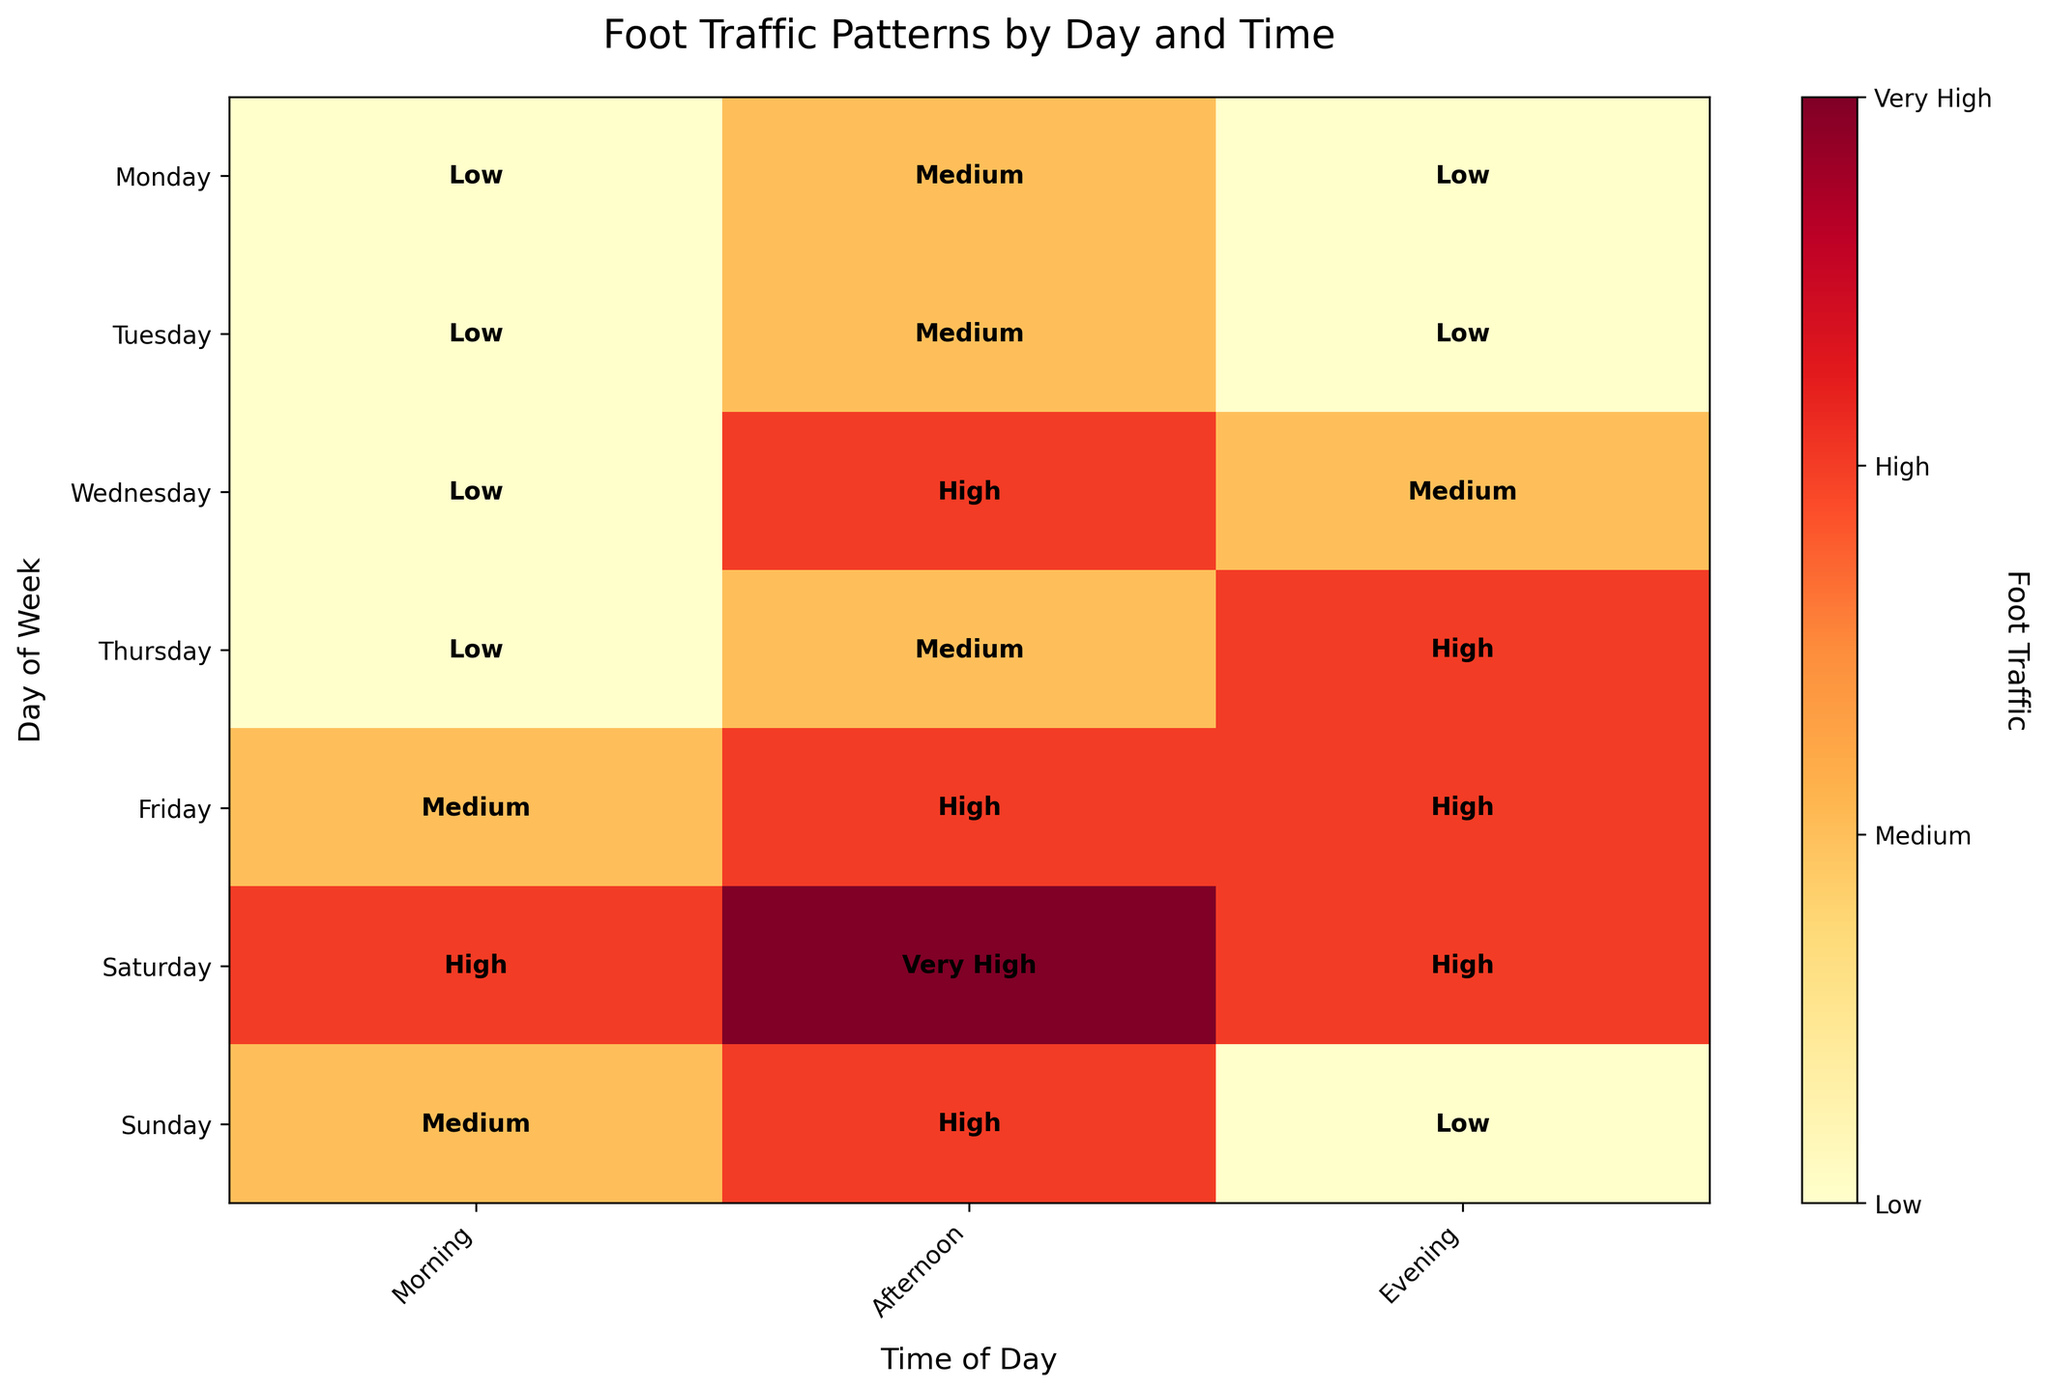What's the title of the plot? The title is usually placed at the top of the plot and provides a brief description of what the plot is about.
Answer: Foot Traffic Patterns by Day and Time Which day has the highest foot traffic in the afternoon? To determine this, locate the "Afternoon" column in the plot and identify the row with the darkest shade of color, which denotes the highest traffic.
Answer: Saturday How does Sunday evening foot traffic compare to Sunday morning foot traffic? Locate both the "Morning" and "Evening" cells for Sunday. Compare their shades—light shades for low traffic and darker shades for higher traffic.
Answer: Evening has lower traffic compared to Morning On which day and time does the foot traffic reach 'Very High'? Identify the darkest cell, which represents 'Very High', in both the days and times shown.
Answer: Saturday Afternoon What day and time of day has the lowest foot traffic overall? Look for the lightest shade in the entire plot, which signifies the lowest foot traffic.
Answer: Monday Morning How does Wednesday evening foot traffic compare to Thursday evening foot traffic? Compare the shades of the cells corresponding to "Wednesday Evening" and "Thursday Evening."
Answer: Thursday has higher traffic Which day has the highest variation in foot traffic across the time of day? Analyze the changes in color shades across different times of day for each row. The highest difference in shades signifies the most variation.
Answer: Friday How does the foot traffic on Friday morning compare to Monday afternoon? Examine the colors for Friday Morning and Monday Afternoon; recall that darker colors indicate higher traffic.
Answer: Friday Morning has higher traffic Which time of day consistently shows low foot traffic across most days? Identify the time of day that mostly contains lighter shades across the corresponding columns for multiple days.
Answer: Morning 